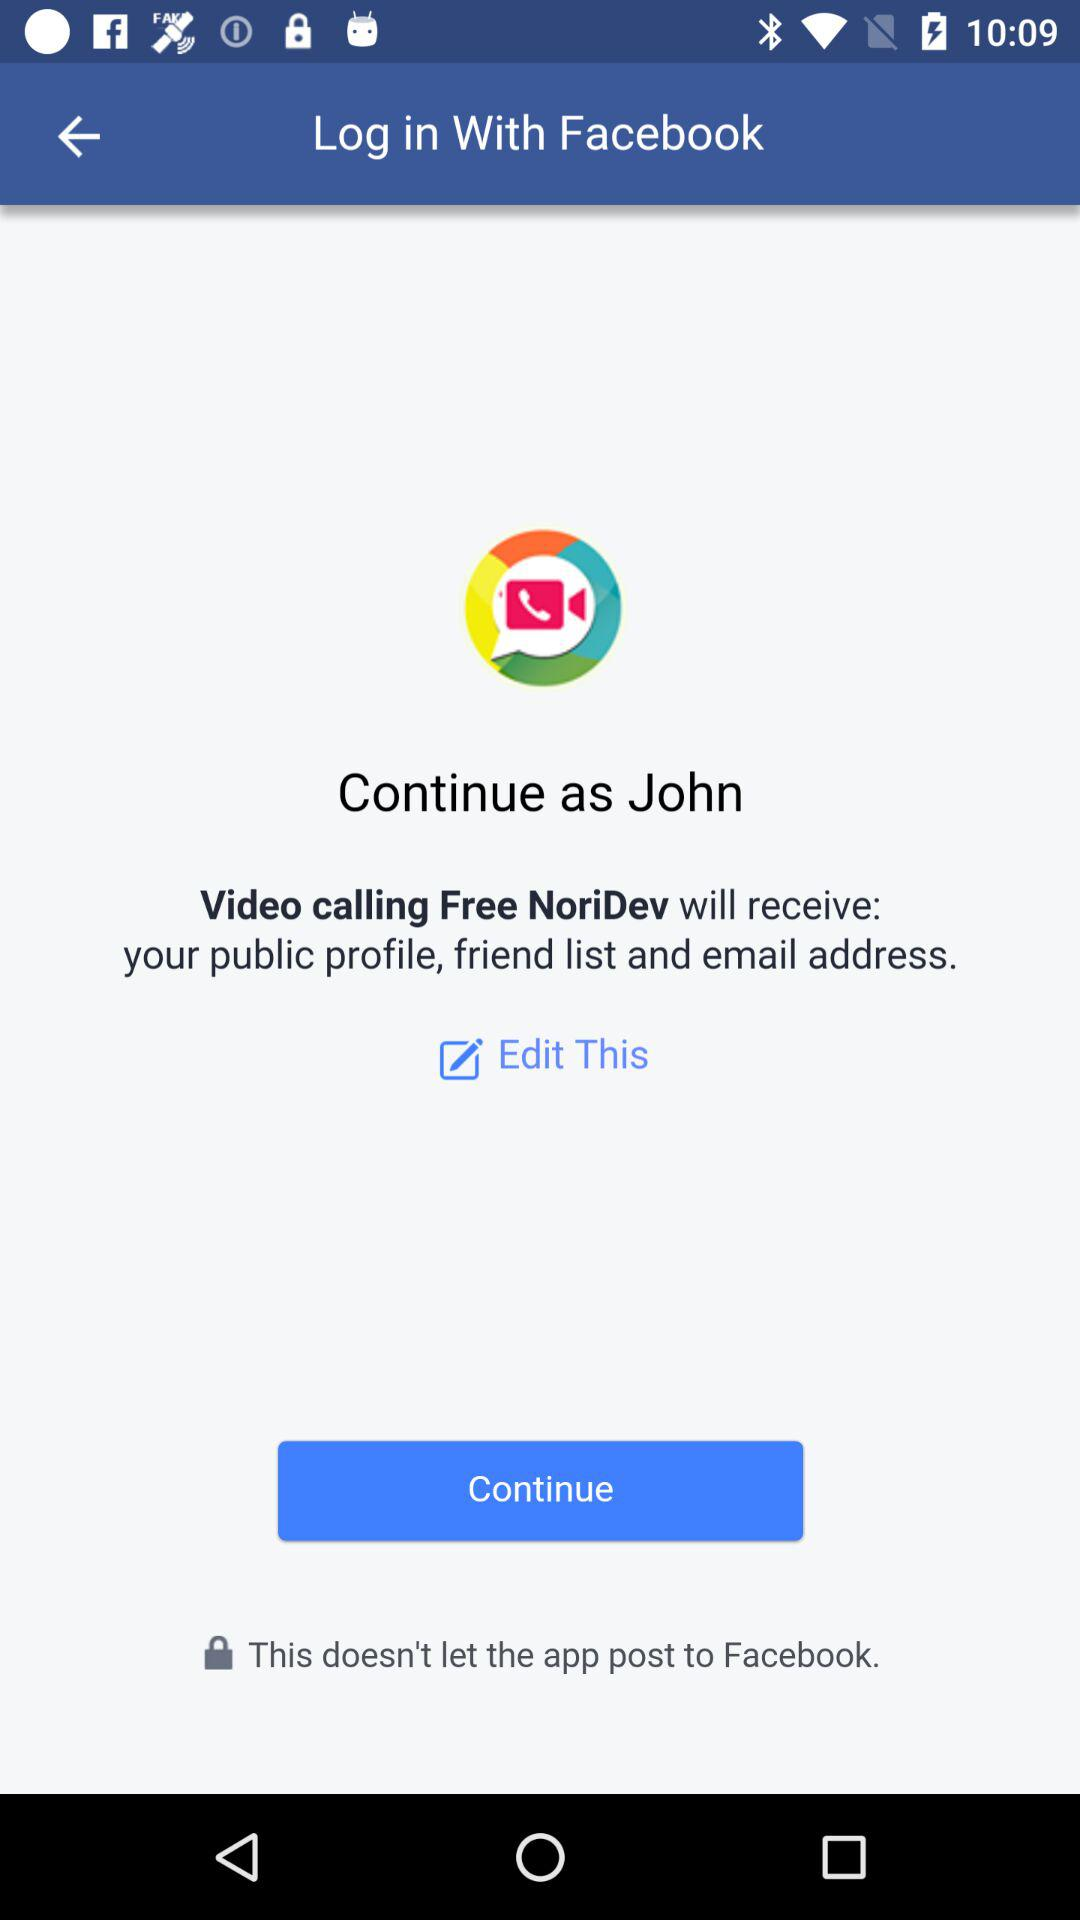How can we log in? You can log in with "Facebook". 